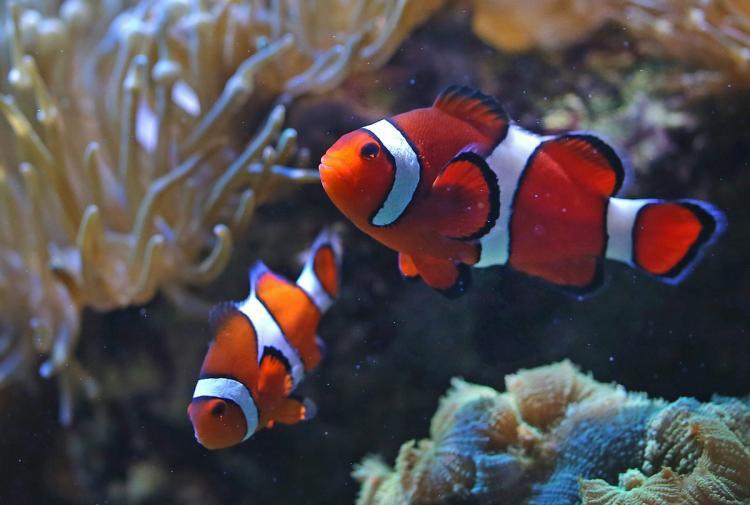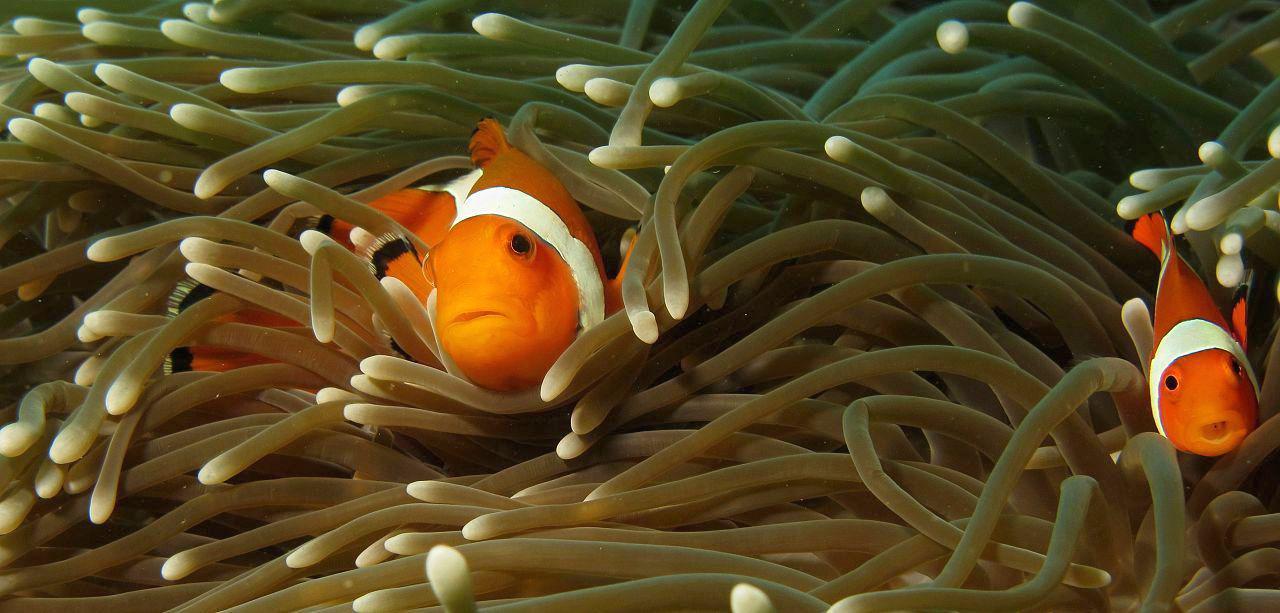The first image is the image on the left, the second image is the image on the right. Considering the images on both sides, is "Three clown fish are shown, in total." valid? Answer yes or no. No. 